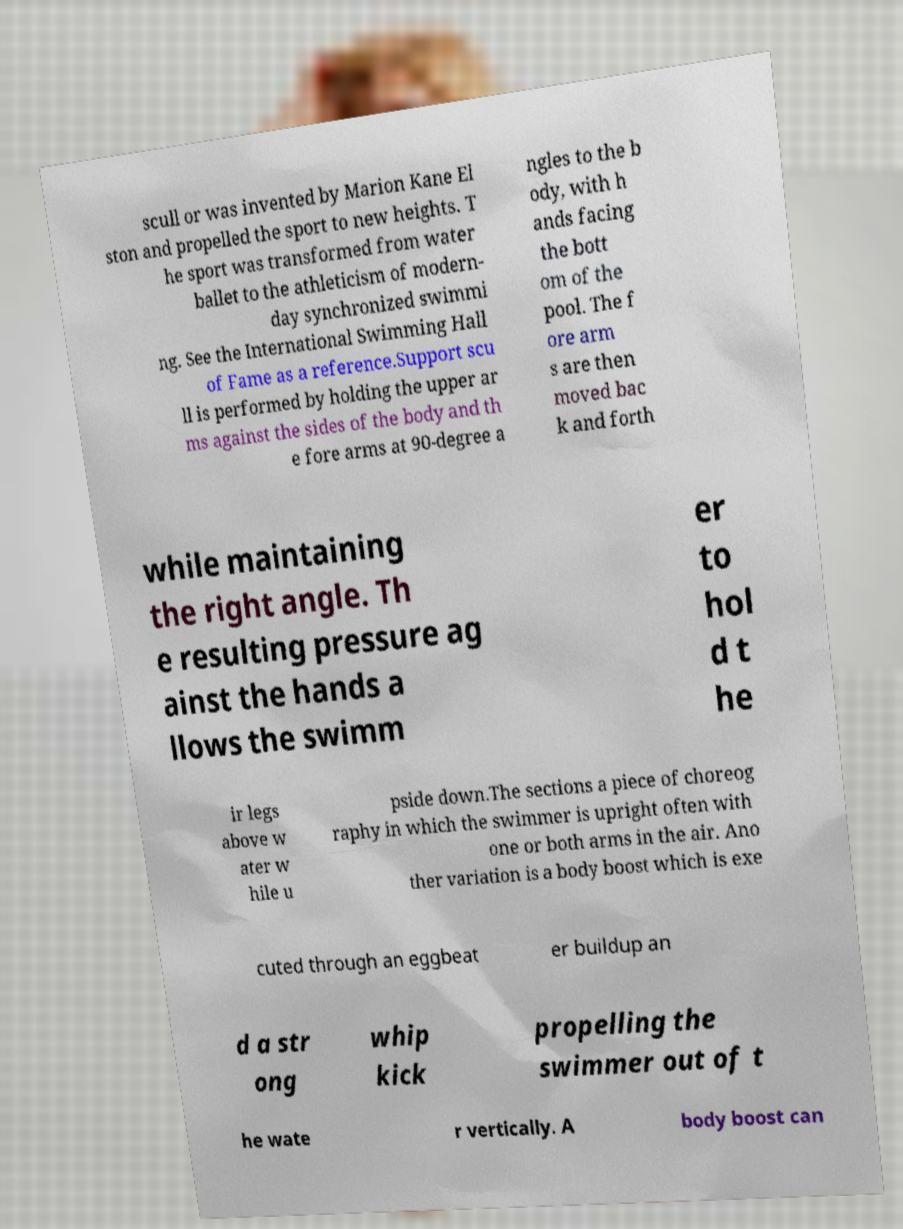What messages or text are displayed in this image? I need them in a readable, typed format. scull or was invented by Marion Kane El ston and propelled the sport to new heights. T he sport was transformed from water ballet to the athleticism of modern- day synchronized swimmi ng. See the International Swimming Hall of Fame as a reference.Support scu ll is performed by holding the upper ar ms against the sides of the body and th e fore arms at 90-degree a ngles to the b ody, with h ands facing the bott om of the pool. The f ore arm s are then moved bac k and forth while maintaining the right angle. Th e resulting pressure ag ainst the hands a llows the swimm er to hol d t he ir legs above w ater w hile u pside down.The sections a piece of choreog raphy in which the swimmer is upright often with one or both arms in the air. Ano ther variation is a body boost which is exe cuted through an eggbeat er buildup an d a str ong whip kick propelling the swimmer out of t he wate r vertically. A body boost can 